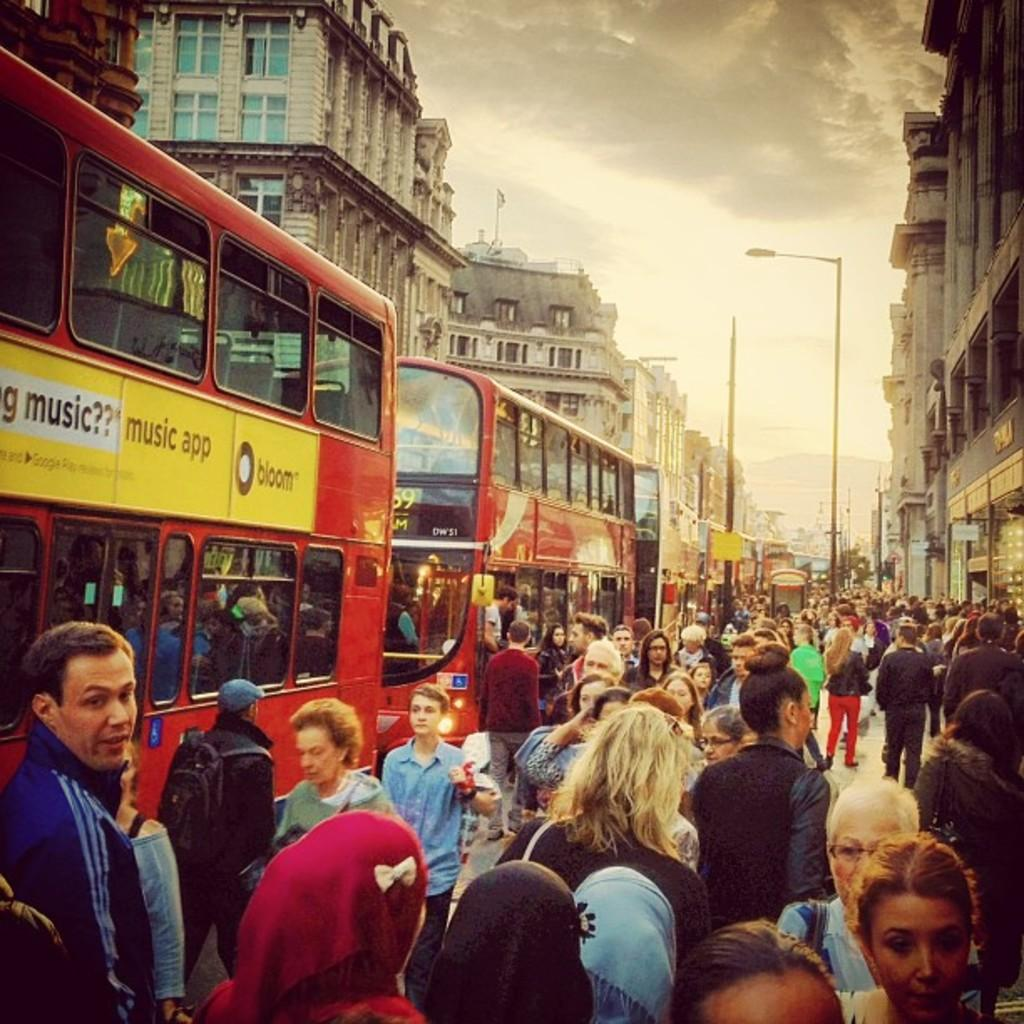<image>
Give a short and clear explanation of the subsequent image. A lot of people are walking by a couple of buses, with a music app advertisement on one. 